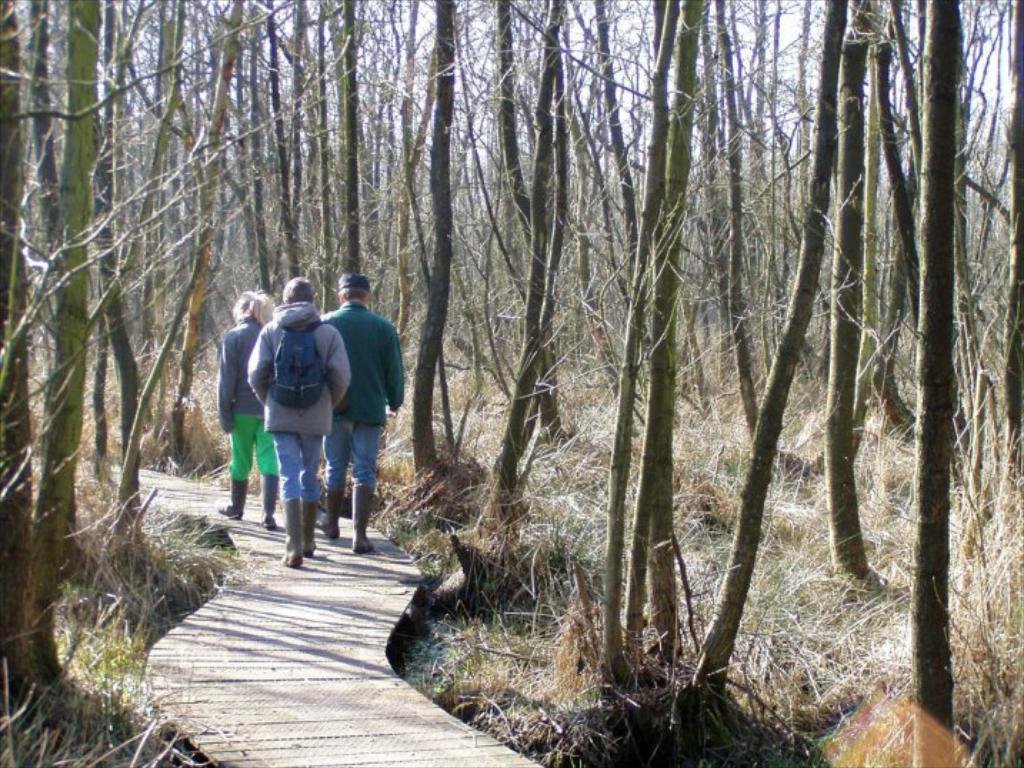What are the people in the image doing? The people in the image are walking on a path. What can be seen alongside the path in the image? There are trees alongside the path in the image. What type of mark can be seen on the trees in the image? There is no mark visible on the trees in the image. What rule might the people walking on the path be following? There is no indication of a rule being followed by the people walking on the path in the image. 